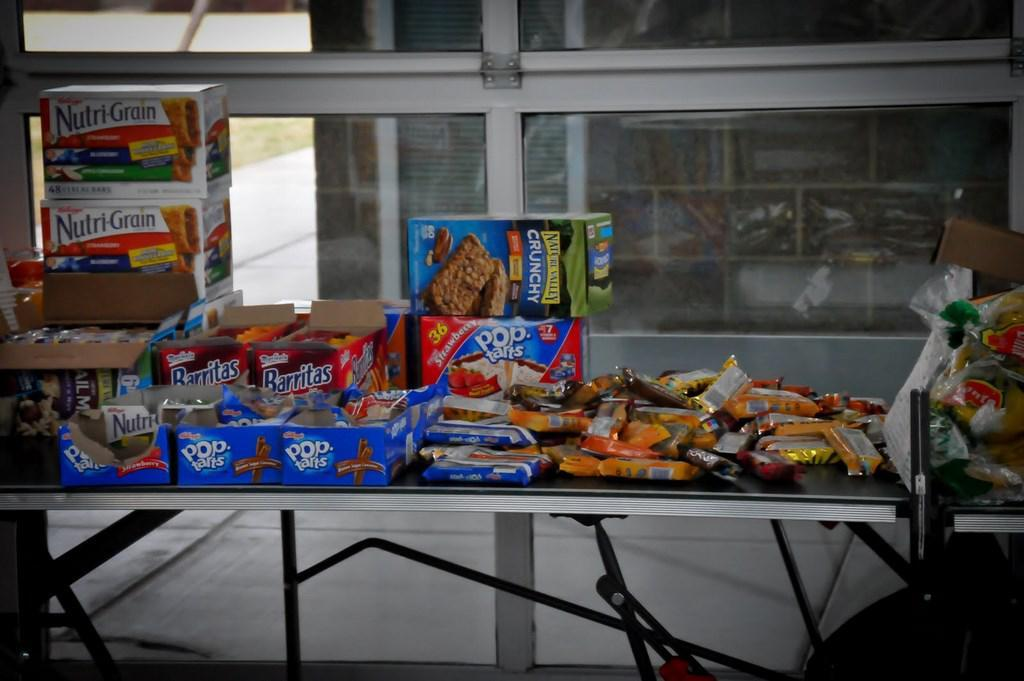What type of food can be seen in the foreground of the image? There are chocolates in the foreground of the image. What is on the table in the foreground of the image? There are cardboard boxes on the table in the foreground. What is visible in the background of the image? There is a glass in the background of the image. What can be seen through the glass in the background? Many objects are visible in the rack through the glass in the background. What type of patch can be seen on the beetle in the image? There are no beetles present in the image, so there is no patch to observe. 